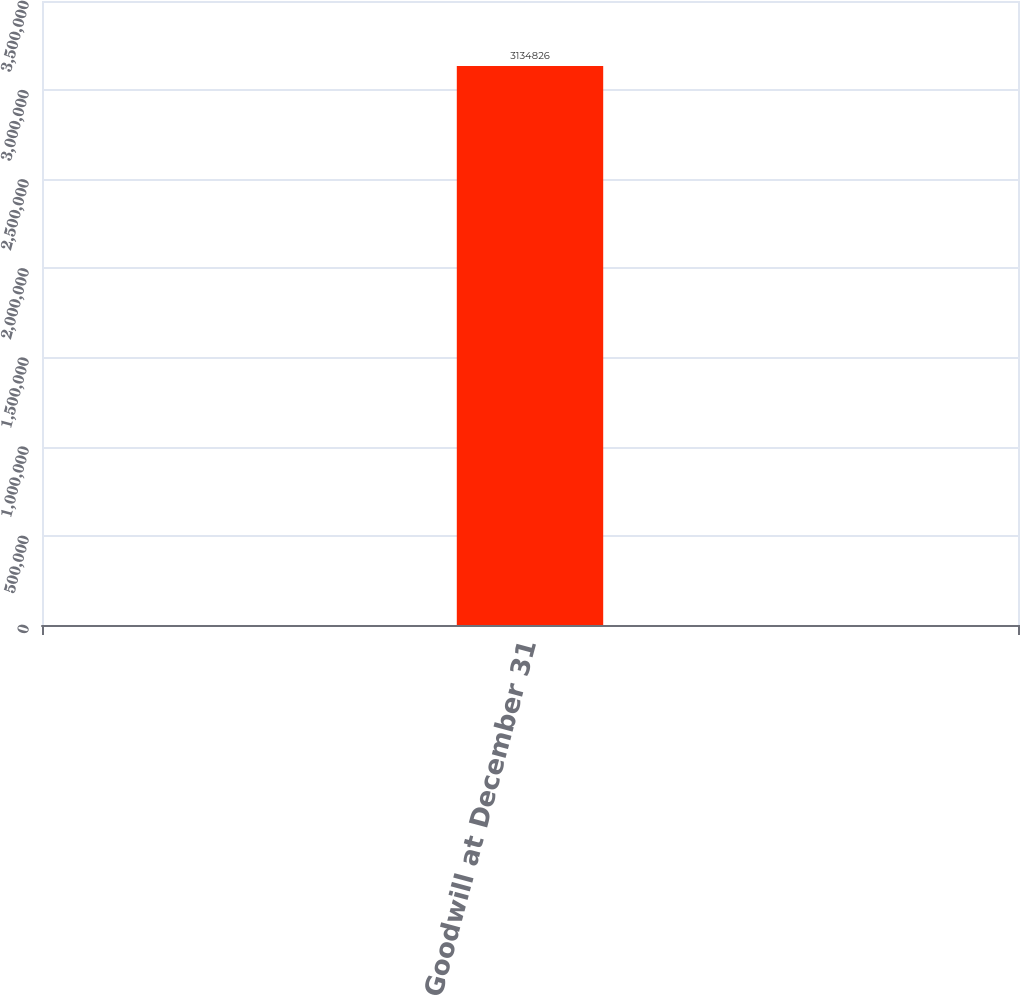Convert chart. <chart><loc_0><loc_0><loc_500><loc_500><bar_chart><fcel>Goodwill at December 31<nl><fcel>3.13483e+06<nl></chart> 